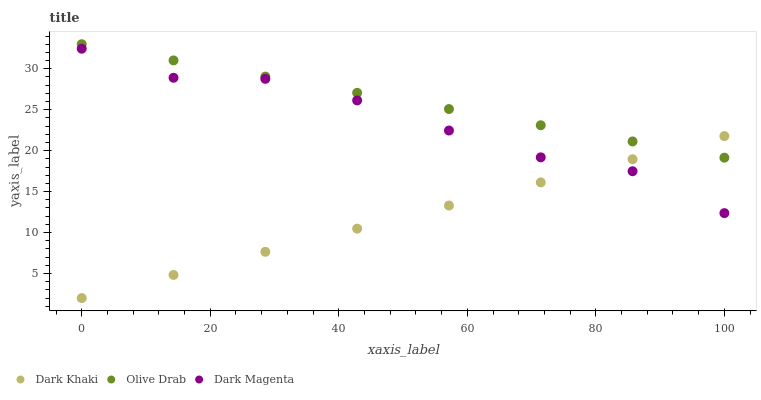Does Dark Khaki have the minimum area under the curve?
Answer yes or no. Yes. Does Olive Drab have the maximum area under the curve?
Answer yes or no. Yes. Does Dark Magenta have the minimum area under the curve?
Answer yes or no. No. Does Dark Magenta have the maximum area under the curve?
Answer yes or no. No. Is Dark Khaki the smoothest?
Answer yes or no. Yes. Is Dark Magenta the roughest?
Answer yes or no. Yes. Is Olive Drab the smoothest?
Answer yes or no. No. Is Olive Drab the roughest?
Answer yes or no. No. Does Dark Khaki have the lowest value?
Answer yes or no. Yes. Does Dark Magenta have the lowest value?
Answer yes or no. No. Does Olive Drab have the highest value?
Answer yes or no. Yes. Does Dark Magenta have the highest value?
Answer yes or no. No. Is Dark Magenta less than Olive Drab?
Answer yes or no. Yes. Is Olive Drab greater than Dark Magenta?
Answer yes or no. Yes. Does Dark Khaki intersect Olive Drab?
Answer yes or no. Yes. Is Dark Khaki less than Olive Drab?
Answer yes or no. No. Is Dark Khaki greater than Olive Drab?
Answer yes or no. No. Does Dark Magenta intersect Olive Drab?
Answer yes or no. No. 